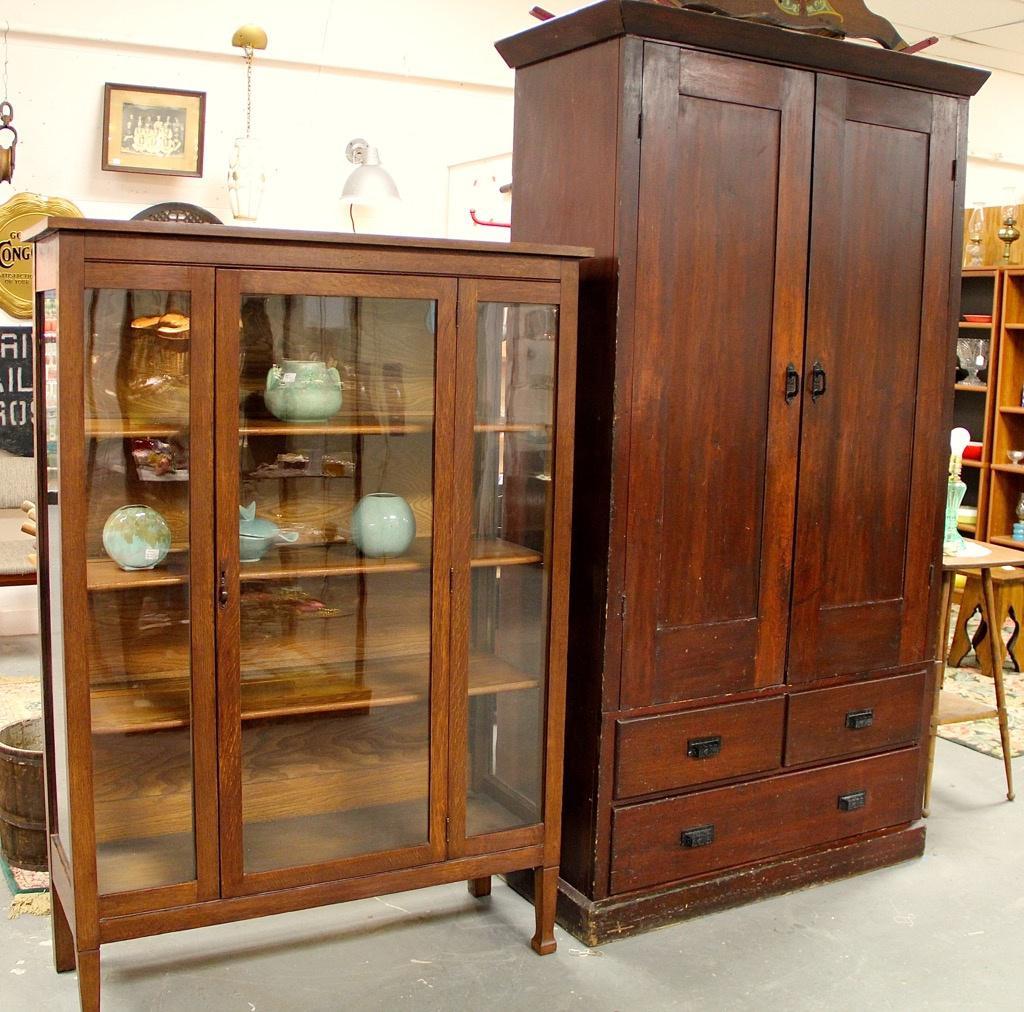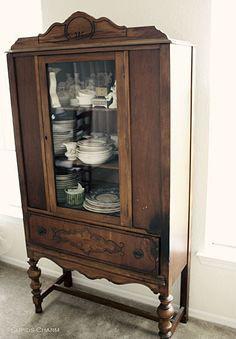The first image is the image on the left, the second image is the image on the right. Analyze the images presented: Is the assertion "All wooden displays feature clear glass and are completely empty." valid? Answer yes or no. No. The first image is the image on the left, the second image is the image on the right. Evaluate the accuracy of this statement regarding the images: "Each image shows an empty rectangular hutch with glass upper cabinet doors.". Is it true? Answer yes or no. No. The first image is the image on the left, the second image is the image on the right. Considering the images on both sides, is "Both images show just one cabinet with legs, and at least one cabinet has curving legs that end in a rounded foot." valid? Answer yes or no. No. The first image is the image on the left, the second image is the image on the right. Analyze the images presented: Is the assertion "There are two glass doors in the image on the left." valid? Answer yes or no. No. 